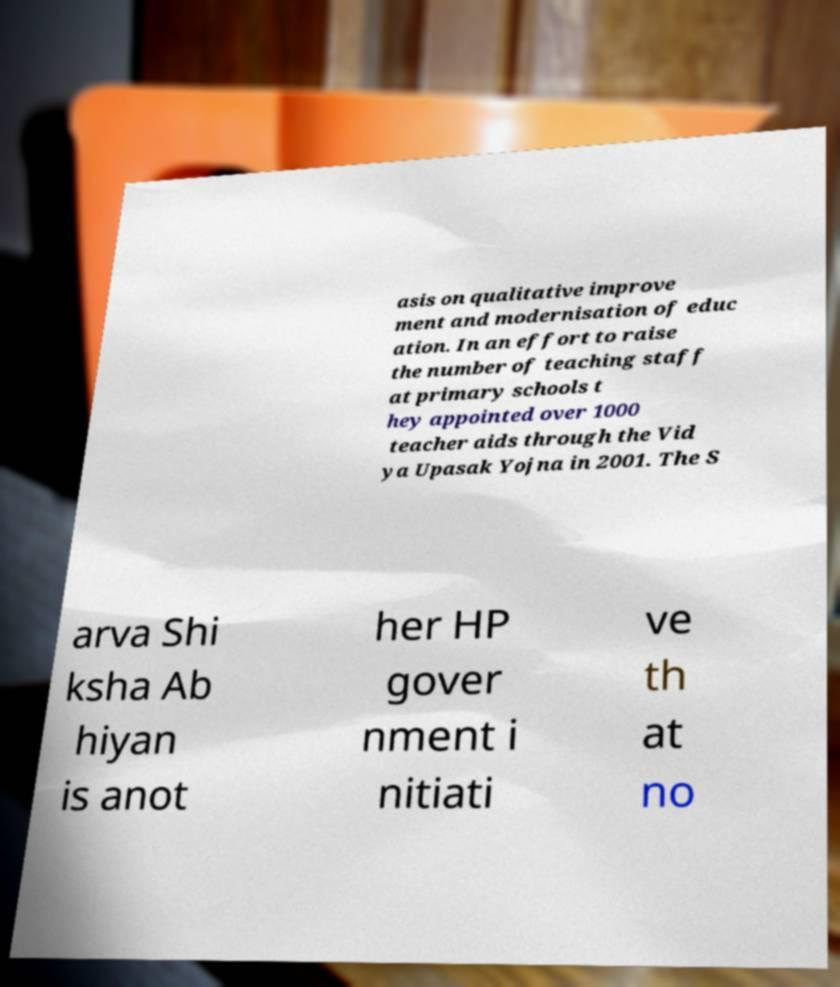What messages or text are displayed in this image? I need them in a readable, typed format. asis on qualitative improve ment and modernisation of educ ation. In an effort to raise the number of teaching staff at primary schools t hey appointed over 1000 teacher aids through the Vid ya Upasak Yojna in 2001. The S arva Shi ksha Ab hiyan is anot her HP gover nment i nitiati ve th at no 